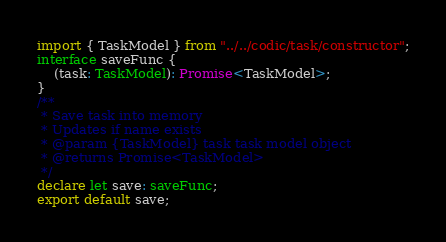Convert code to text. <code><loc_0><loc_0><loc_500><loc_500><_TypeScript_>import { TaskModel } from "../../codic/task/constructor";
interface saveFunc {
    (task: TaskModel): Promise<TaskModel>;
}
/**
 * Save task into memory
 * Updates if name exists
 * @param {TaskModel} task task model object
 * @returns Promise<TaskModel>
 */
declare let save: saveFunc;
export default save;
</code> 